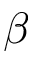<formula> <loc_0><loc_0><loc_500><loc_500>\beta</formula> 